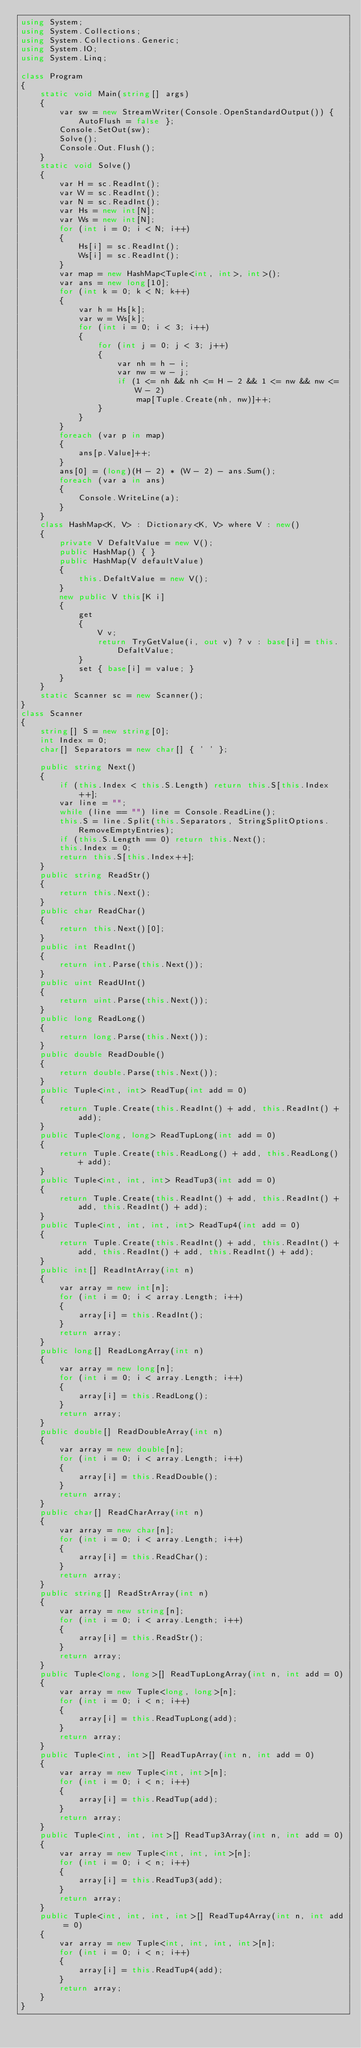Convert code to text. <code><loc_0><loc_0><loc_500><loc_500><_C#_>using System;
using System.Collections;
using System.Collections.Generic;
using System.IO;
using System.Linq;

class Program
{
    static void Main(string[] args)
    {
        var sw = new StreamWriter(Console.OpenStandardOutput()) { AutoFlush = false };
        Console.SetOut(sw);
        Solve();
        Console.Out.Flush();
    }
    static void Solve()
    {
        var H = sc.ReadInt();
        var W = sc.ReadInt();
        var N = sc.ReadInt();
        var Hs = new int[N];
        var Ws = new int[N];
        for (int i = 0; i < N; i++)
        {
            Hs[i] = sc.ReadInt();
            Ws[i] = sc.ReadInt();
        }
        var map = new HashMap<Tuple<int, int>, int>();
        var ans = new long[10];
        for (int k = 0; k < N; k++)
        {
            var h = Hs[k];
            var w = Ws[k];
            for (int i = 0; i < 3; i++)
            {
                for (int j = 0; j < 3; j++)
                {
                    var nh = h - i;
                    var nw = w - j;
                    if (1 <= nh && nh <= H - 2 && 1 <= nw && nw <= W - 2)
                        map[Tuple.Create(nh, nw)]++;
                }
            }
        }
        foreach (var p in map)
        {
            ans[p.Value]++;
        }
        ans[0] = (long)(H - 2) * (W - 2) - ans.Sum();
        foreach (var a in ans)
        {
            Console.WriteLine(a);
        }
    }
    class HashMap<K, V> : Dictionary<K, V> where V : new()
    {
        private V DefaltValue = new V();
        public HashMap() { }
        public HashMap(V defaultValue)
        {
            this.DefaltValue = new V();
        }
        new public V this[K i]
        {
            get
            {
                V v;
                return TryGetValue(i, out v) ? v : base[i] = this.DefaltValue;
            }
            set { base[i] = value; }
        }
    }
    static Scanner sc = new Scanner();
}
class Scanner
{
    string[] S = new string[0];
    int Index = 0;
    char[] Separators = new char[] { ' ' };

    public string Next()
    {
        if (this.Index < this.S.Length) return this.S[this.Index++];
        var line = "";
        while (line == "") line = Console.ReadLine();
        this.S = line.Split(this.Separators, StringSplitOptions.RemoveEmptyEntries);
        if (this.S.Length == 0) return this.Next();
        this.Index = 0;
        return this.S[this.Index++];
    }
    public string ReadStr()
    {
        return this.Next();
    }
    public char ReadChar()
    {
        return this.Next()[0];
    }
    public int ReadInt()
    {
        return int.Parse(this.Next());
    }
    public uint ReadUInt()
    {
        return uint.Parse(this.Next());
    }
    public long ReadLong()
    {
        return long.Parse(this.Next());
    }
    public double ReadDouble()
    {
        return double.Parse(this.Next());
    }
    public Tuple<int, int> ReadTup(int add = 0)
    {
        return Tuple.Create(this.ReadInt() + add, this.ReadInt() + add);
    }
    public Tuple<long, long> ReadTupLong(int add = 0)
    {
        return Tuple.Create(this.ReadLong() + add, this.ReadLong() + add);
    }
    public Tuple<int, int, int> ReadTup3(int add = 0)
    {
        return Tuple.Create(this.ReadInt() + add, this.ReadInt() + add, this.ReadInt() + add);
    }
    public Tuple<int, int, int, int> ReadTup4(int add = 0)
    {
        return Tuple.Create(this.ReadInt() + add, this.ReadInt() + add, this.ReadInt() + add, this.ReadInt() + add);
    }
    public int[] ReadIntArray(int n)
    {
        var array = new int[n];
        for (int i = 0; i < array.Length; i++)
        {
            array[i] = this.ReadInt();
        }
        return array;
    }
    public long[] ReadLongArray(int n)
    {
        var array = new long[n];
        for (int i = 0; i < array.Length; i++)
        {
            array[i] = this.ReadLong();
        }
        return array;
    }
    public double[] ReadDoubleArray(int n)
    {
        var array = new double[n];
        for (int i = 0; i < array.Length; i++)
        {
            array[i] = this.ReadDouble();
        }
        return array;
    }
    public char[] ReadCharArray(int n)
    {
        var array = new char[n];
        for (int i = 0; i < array.Length; i++)
        {
            array[i] = this.ReadChar();
        }
        return array;
    }
    public string[] ReadStrArray(int n)
    {
        var array = new string[n];
        for (int i = 0; i < array.Length; i++)
        {
            array[i] = this.ReadStr();
        }
        return array;
    }
    public Tuple<long, long>[] ReadTupLongArray(int n, int add = 0)
    {
        var array = new Tuple<long, long>[n];
        for (int i = 0; i < n; i++)
        {
            array[i] = this.ReadTupLong(add);
        }
        return array;
    }
    public Tuple<int, int>[] ReadTupArray(int n, int add = 0)
    {
        var array = new Tuple<int, int>[n];
        for (int i = 0; i < n; i++)
        {
            array[i] = this.ReadTup(add);
        }
        return array;
    }
    public Tuple<int, int, int>[] ReadTup3Array(int n, int add = 0)
    {
        var array = new Tuple<int, int, int>[n];
        for (int i = 0; i < n; i++)
        {
            array[i] = this.ReadTup3(add);
        }
        return array;
    }
    public Tuple<int, int, int, int>[] ReadTup4Array(int n, int add = 0)
    {
        var array = new Tuple<int, int, int, int>[n];
        for (int i = 0; i < n; i++)
        {
            array[i] = this.ReadTup4(add);
        }
        return array;
    }
}
</code> 